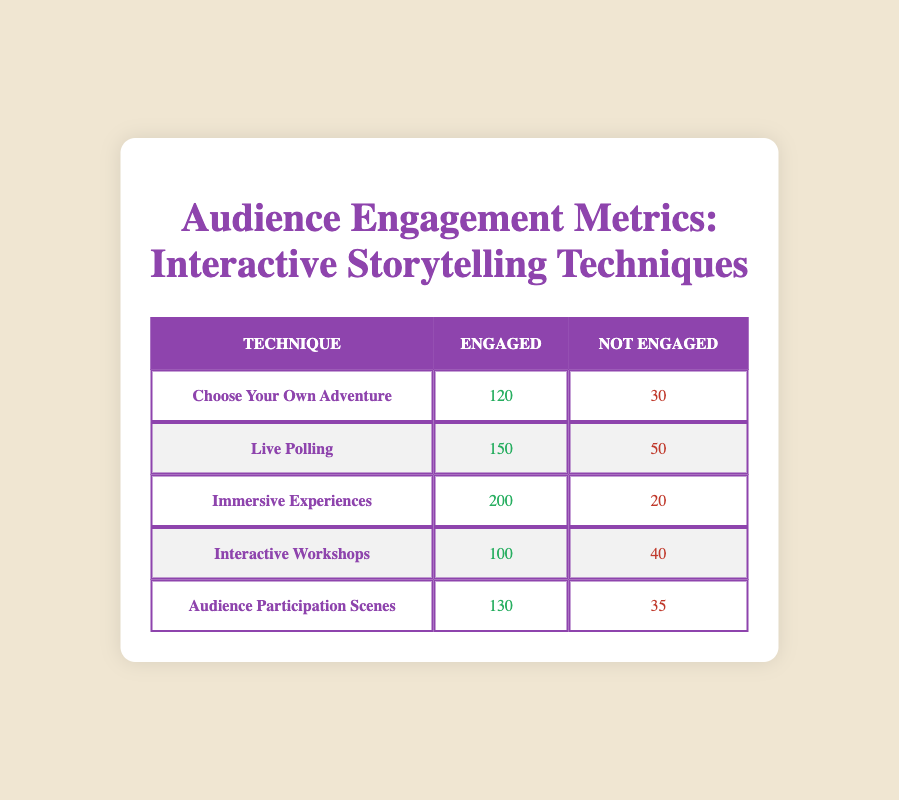What is the total number of engaged audience members for all techniques combined? To find the total engaged audience, I will add the numbers in the "Engaged" column: 120 (Choose Your Own Adventure) + 150 (Live Polling) + 200 (Immersive Experiences) + 100 (Interactive Workshops) + 130 (Audience Participation Scenes) = 700.
Answer: 700 Which technique had the highest number of not engaged audience members? I will compare the "Not Engaged" values: Choose Your Own Adventure (30), Live Polling (50), Immersive Experiences (20), Interactive Workshops (40), and Audience Participation Scenes (35). The highest value is 50 from Live Polling.
Answer: Live Polling What is the percentage of engaged audience members for Immersive Experiences? First, I will determine the total audience for Immersive Experiences: 200 engaged + 20 not engaged = 220 total. Then, calculate the engaged percentage: (200 engaged / 220 total) * 100 = approximately 90.91%.
Answer: 90.91% Is it true that Audience Participation Scenes had more engaged audience members than Interactive Workshops? I compare the "Engaged" numbers: Audience Participation Scenes has 130 engaged while Interactive Workshops has 100 engaged. Since 130 is greater than 100, the statement is true.
Answer: Yes What is the average number of not engaged audience members across all techniques? To find the average, I will sum the "Not Engaged" values: 30 + 50 + 20 + 40 + 35 = 175, then divide by the number of techniques (5): 175 / 5 = 35.
Answer: 35 